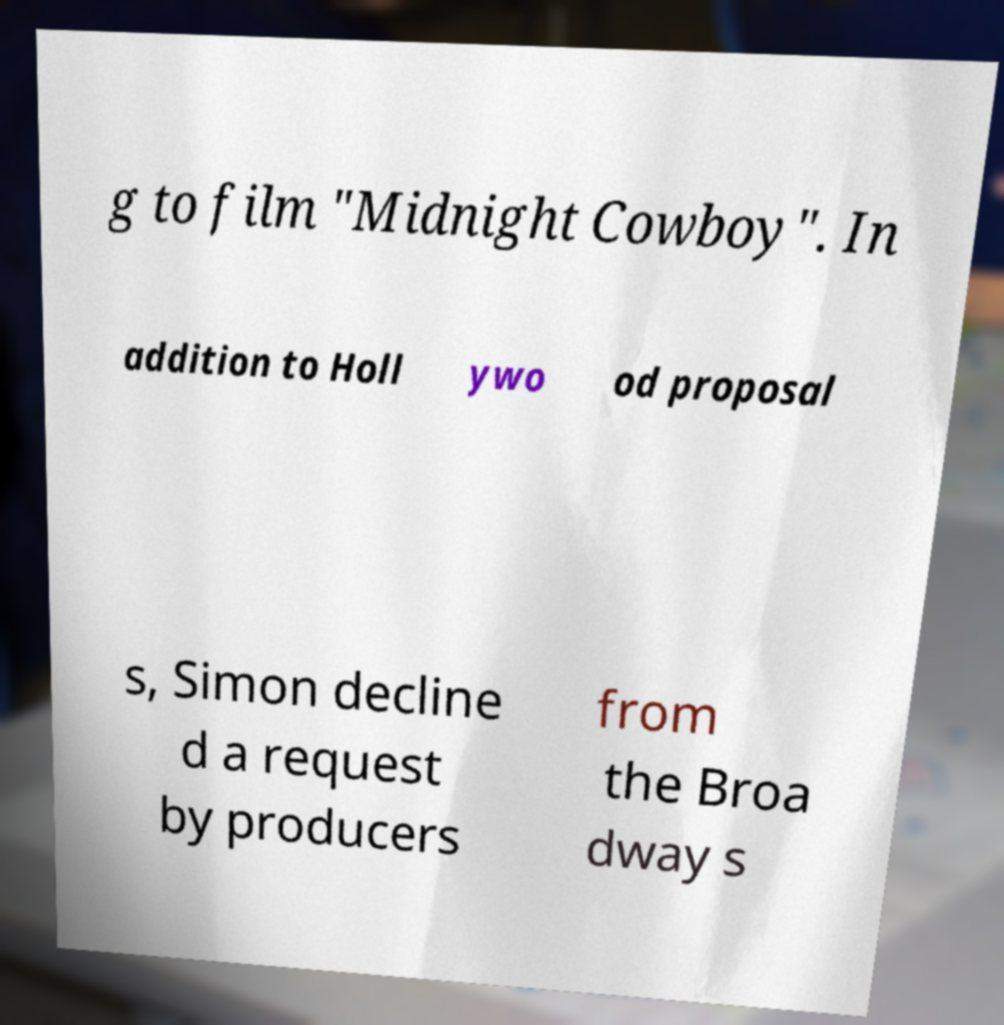I need the written content from this picture converted into text. Can you do that? g to film "Midnight Cowboy". In addition to Holl ywo od proposal s, Simon decline d a request by producers from the Broa dway s 